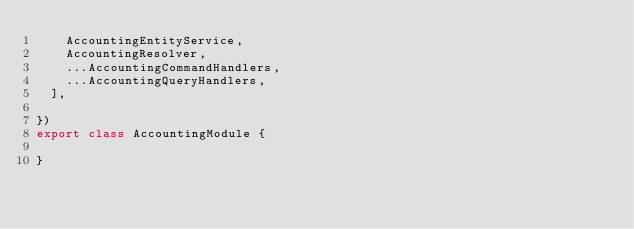<code> <loc_0><loc_0><loc_500><loc_500><_TypeScript_>    AccountingEntityService,
    AccountingResolver,
    ...AccountingCommandHandlers,
    ...AccountingQueryHandlers,
  ],

})
export class AccountingModule {

}
</code> 